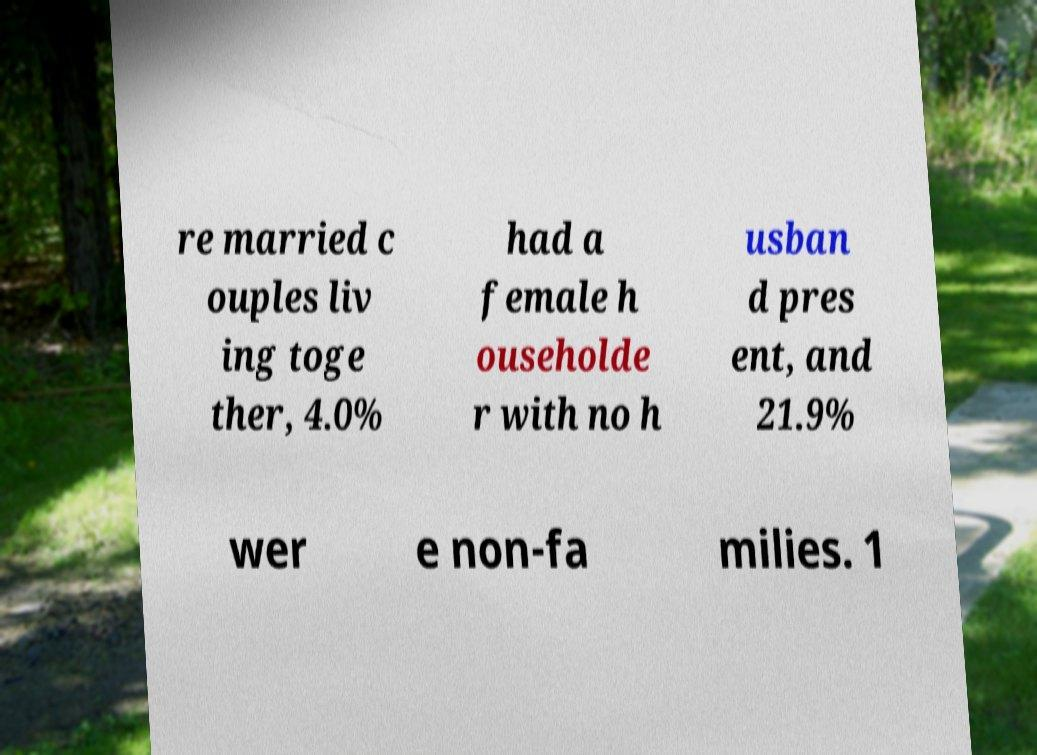Could you extract and type out the text from this image? re married c ouples liv ing toge ther, 4.0% had a female h ouseholde r with no h usban d pres ent, and 21.9% wer e non-fa milies. 1 